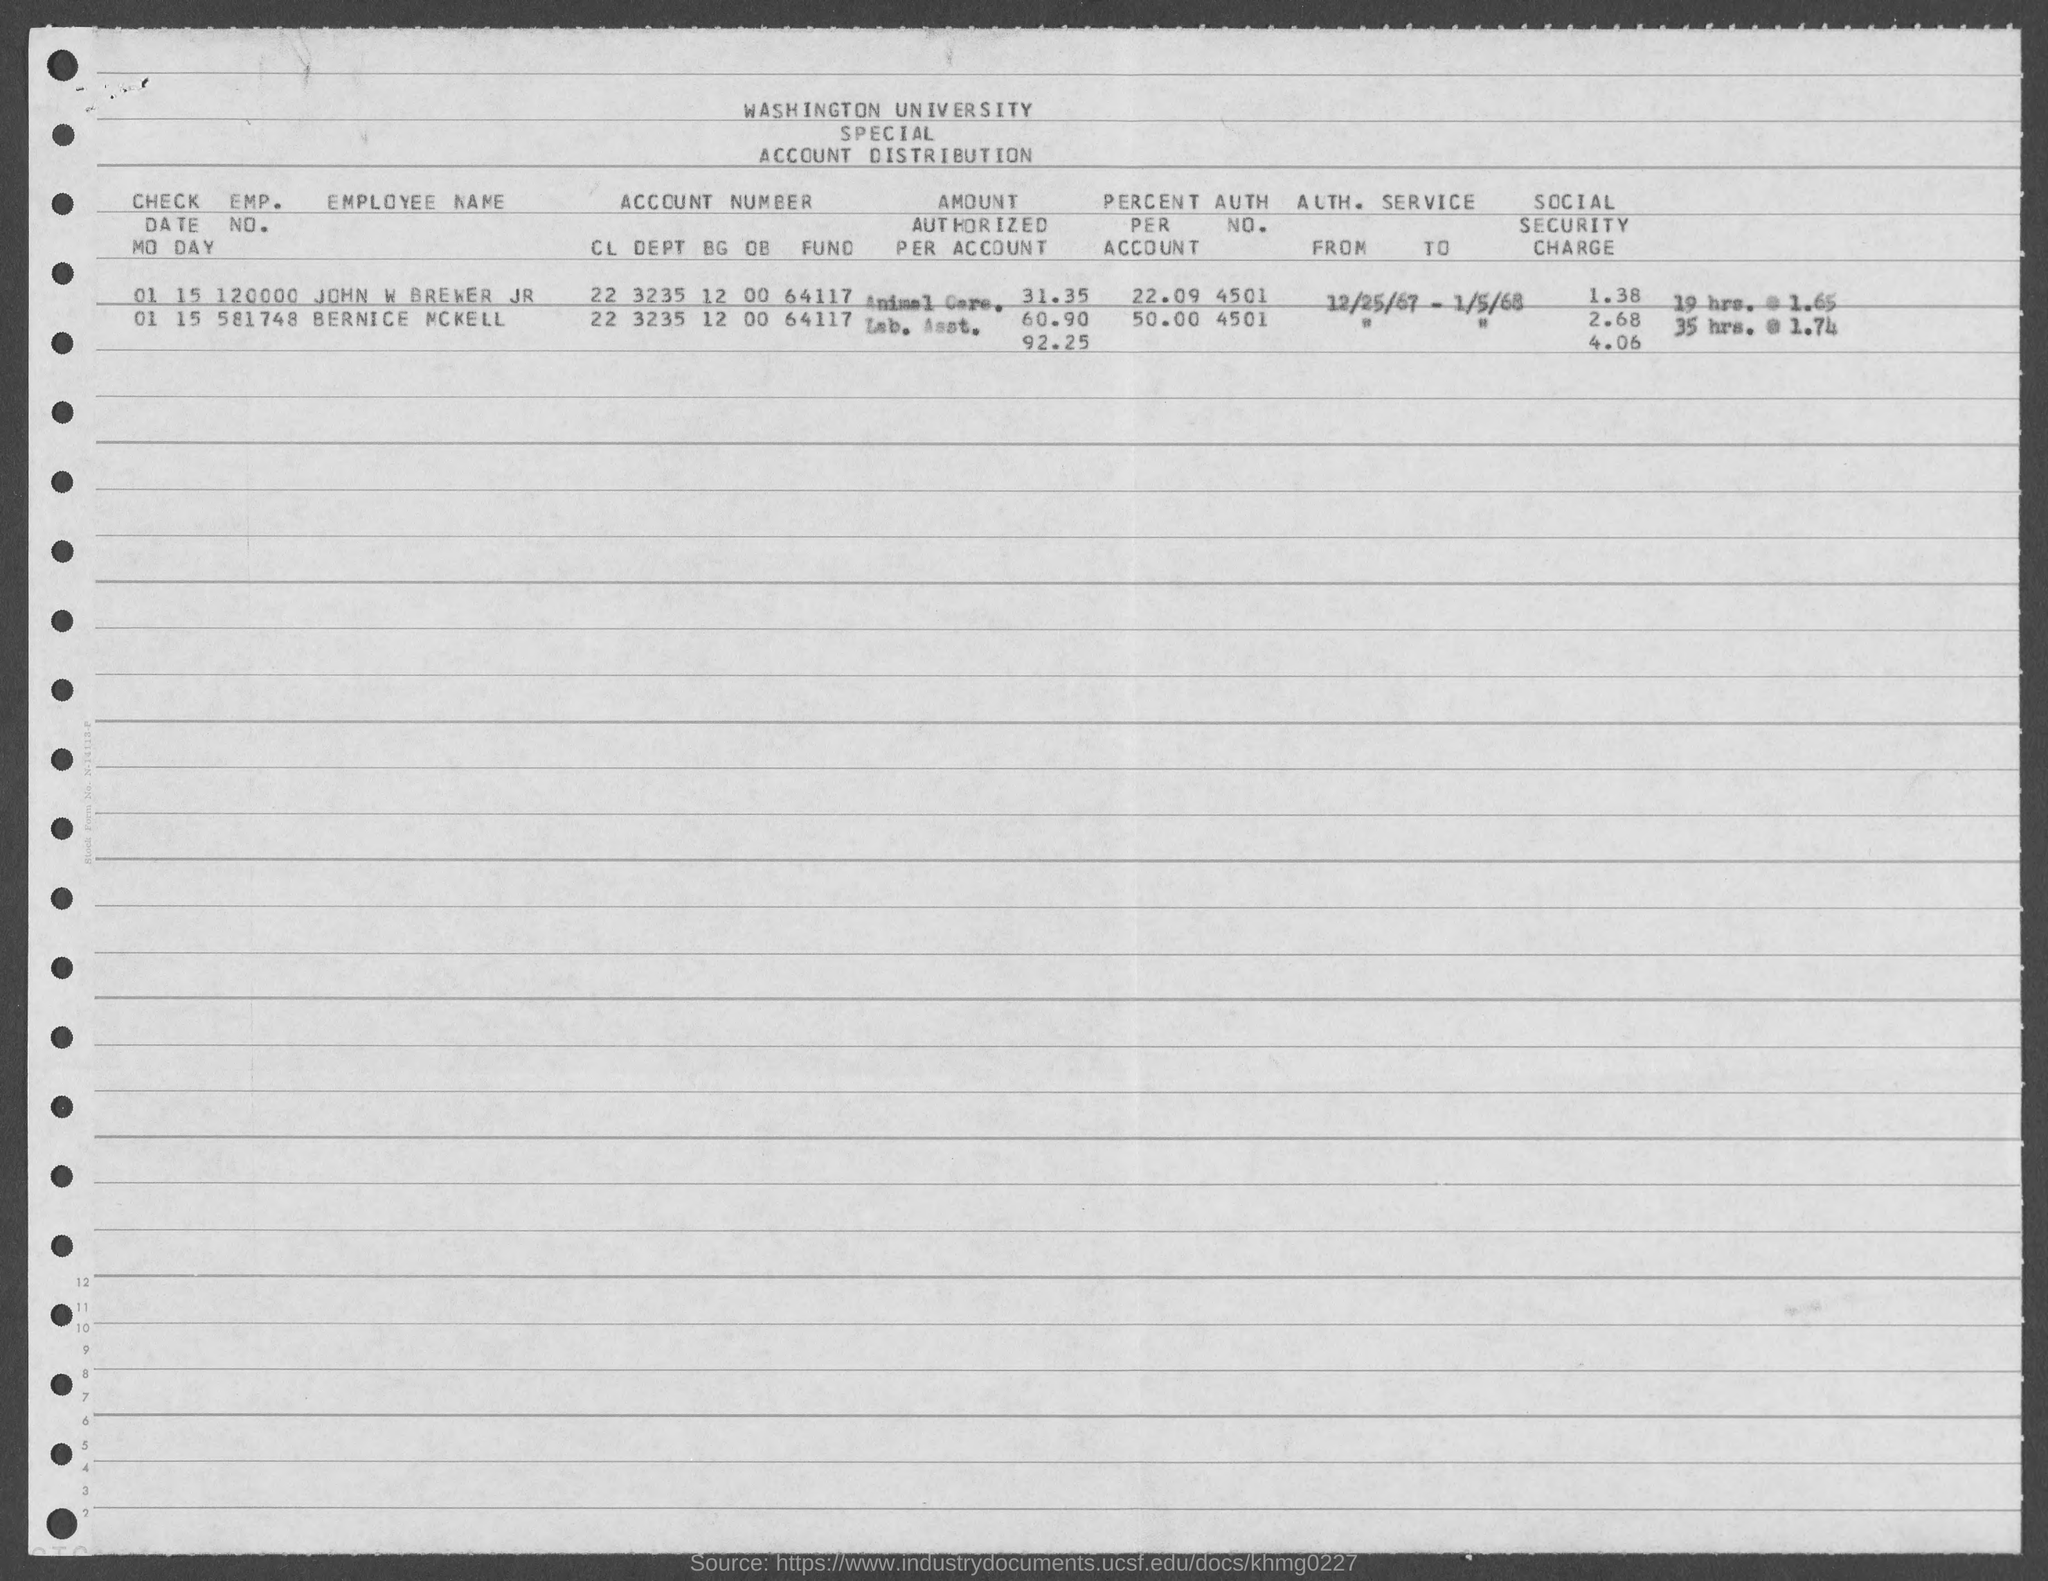List a handful of essential elements in this visual. The emp. no. of John W Brewer is 120000, as mentioned on the given page. The account number of Bernice McKell as mentioned on the given page is 22 3235 12 00 64117. The employee number of Bernice McKell, as mentioned in the provided form, is 581748... The account number of John W. Brewer Jr. as mentioned in the given page is 22 3235 12 00 64117. 